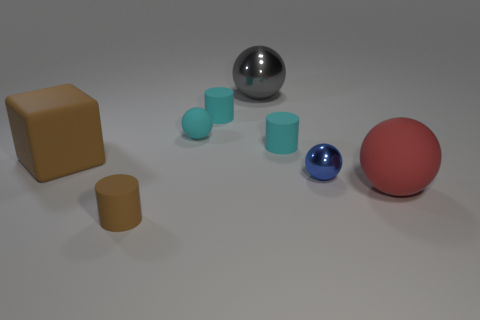What number of tiny things are either gray metallic things or cyan rubber objects?
Offer a very short reply. 3. Are there any other things that have the same color as the small metal sphere?
Offer a terse response. No. Is the size of the matte cylinder that is in front of the red matte ball the same as the large red thing?
Your answer should be very brief. No. The small ball that is to the right of the small rubber cylinder that is on the right side of the gray object to the right of the brown cylinder is what color?
Your answer should be very brief. Blue. The large metallic thing has what color?
Give a very brief answer. Gray. Do the small matte sphere and the big metallic thing have the same color?
Offer a very short reply. No. Is the material of the brown object behind the brown rubber cylinder the same as the large sphere that is in front of the small blue metallic sphere?
Your answer should be compact. Yes. What material is the blue object that is the same shape as the large red rubber thing?
Keep it short and to the point. Metal. Do the gray ball and the small brown cylinder have the same material?
Offer a terse response. No. There is a tiny ball that is on the right side of the matte sphere that is behind the red matte sphere; what color is it?
Your answer should be very brief. Blue. 